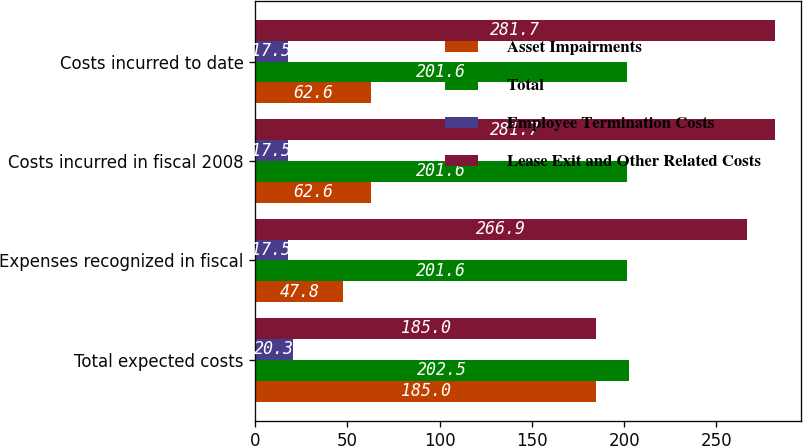Convert chart to OTSL. <chart><loc_0><loc_0><loc_500><loc_500><stacked_bar_chart><ecel><fcel>Total expected costs<fcel>Expenses recognized in fiscal<fcel>Costs incurred in fiscal 2008<fcel>Costs incurred to date<nl><fcel>Asset Impairments<fcel>185<fcel>47.8<fcel>62.6<fcel>62.6<nl><fcel>Total<fcel>202.5<fcel>201.6<fcel>201.6<fcel>201.6<nl><fcel>Employee Termination Costs<fcel>20.3<fcel>17.5<fcel>17.5<fcel>17.5<nl><fcel>Lease Exit and Other Related Costs<fcel>185<fcel>266.9<fcel>281.7<fcel>281.7<nl></chart> 